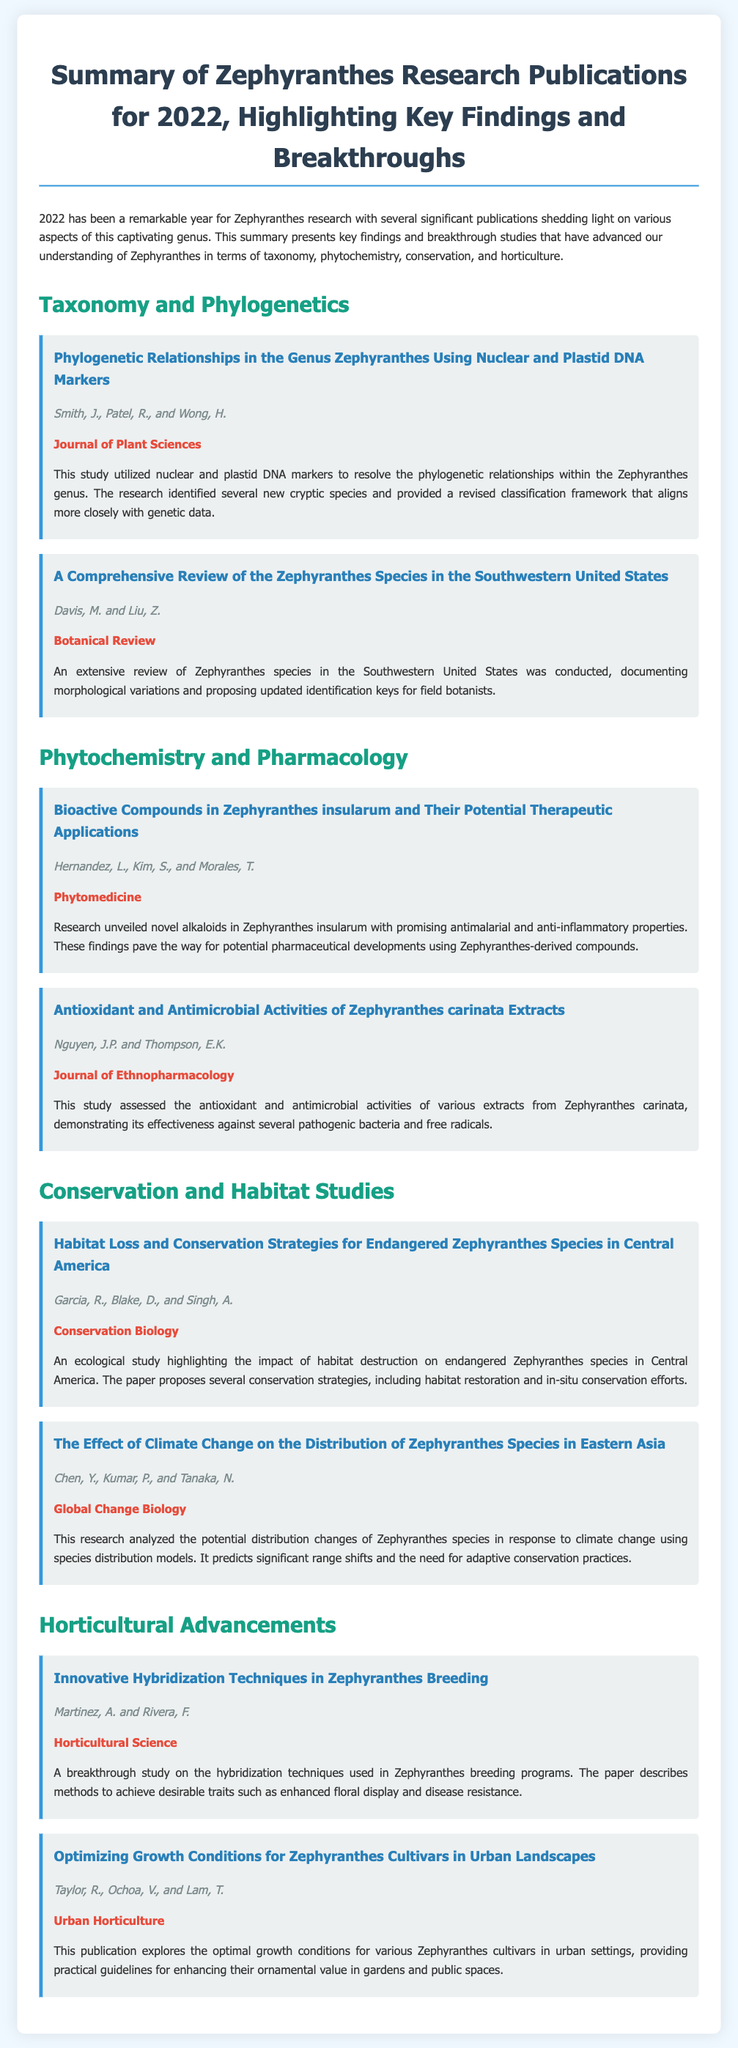What is the title of the document? The title is explicitly stated in the header section of the document.
Answer: Summary of Zephyranthes Research Publications for 2022, Highlighting Key Findings and Breakthroughs Who are the authors of the publication on phylogenetic relationships? This information is found in the section discussing taxonomy and phylogenetics.
Answer: Smith, J., Patel, R., and Wong, H What journal published the study on bioactive compounds in Zephyranthes insularum? The journal name is provided below the respective publication title.
Answer: Phytomedicine How many publications are highlighted under the Horticultural Advancements section? This information can be counted in the respective section of the document.
Answer: Two What new findings were reported in the study about Zephyranthes species in Central America? This requires reasoning about the presented research findings in conservation.
Answer: Proposed several conservation strategies Which species is discussed in the study assessing antioxidant and antimicrobial activities? This information can be retrieved from the respective publication title in the phytochemistry section.
Answer: Zephyranthes carinata What technique is emphasized in the study about Zephyranthes breeding programs? This is found in the title of the publication that discusses horticultural advancements.
Answer: Hybridization techniques What year does the document summarize for Zephyranthes research? The introduction provides a specific year that the research summaries pertain to.
Answer: 2022 